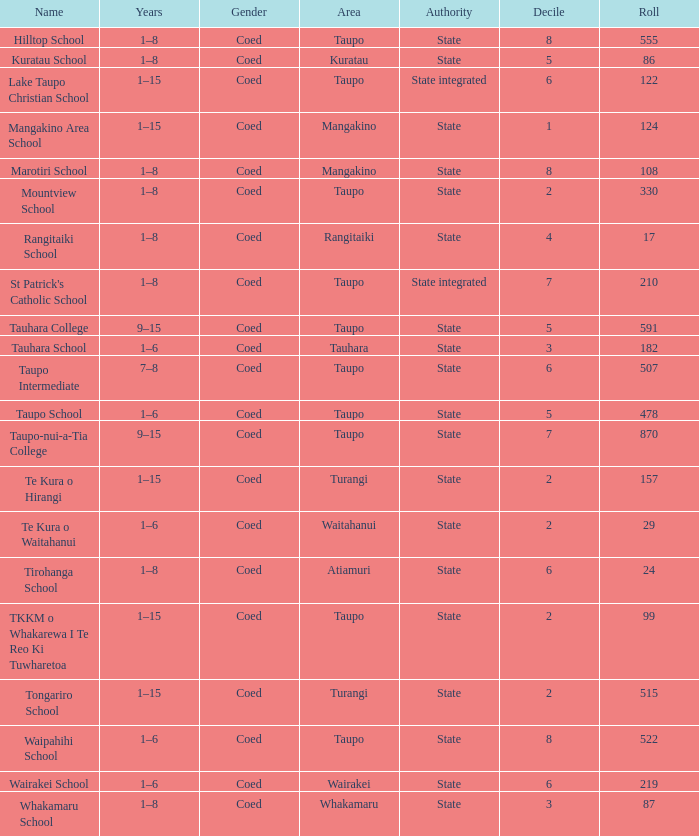Where is the state-controlled educational institution that consists of more than 157 enrolled students located? Taupo, Taupo, Taupo, Tauhara, Taupo, Taupo, Taupo, Turangi, Taupo, Wairakei. 